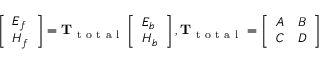Convert formula to latex. <formula><loc_0><loc_0><loc_500><loc_500>\left [ \begin{array} { l } { E _ { f } } \\ { H _ { f } } \end{array} \right ] = T _ { t o t a l } \left [ \begin{array} { l } { E _ { b } } \\ { H _ { b } } \end{array} \right ] , T _ { t o t a l } = \left [ \begin{array} { c c } { A } & { B } \\ { C } & { D } \end{array} \right ]</formula> 